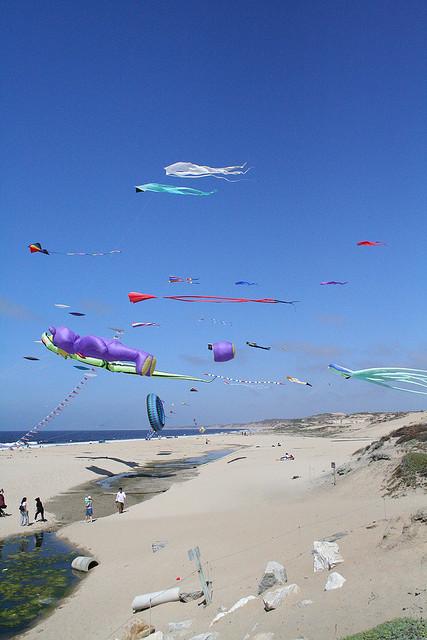How many kites are in the image?
Be succinct. 17. Where was this photo taken?
Concise answer only. Beach. How many clouds are above the kites?
Concise answer only. 0. What's the weather like?
Write a very short answer. Windy. 